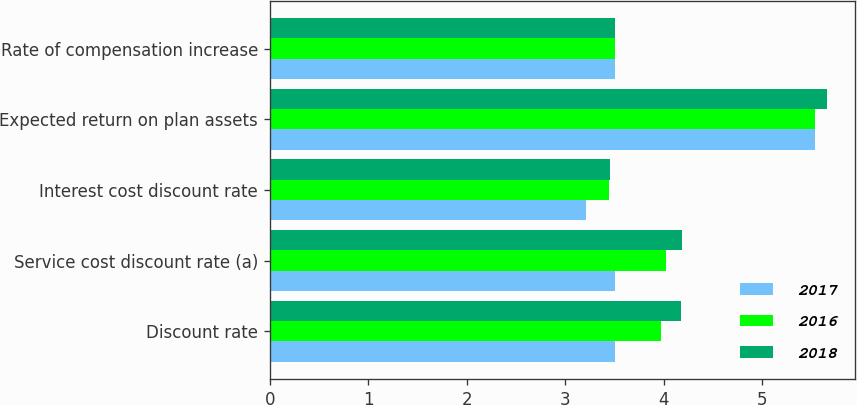Convert chart. <chart><loc_0><loc_0><loc_500><loc_500><stacked_bar_chart><ecel><fcel>Discount rate<fcel>Service cost discount rate (a)<fcel>Interest cost discount rate<fcel>Expected return on plan assets<fcel>Rate of compensation increase<nl><fcel>2017<fcel>3.51<fcel>3.5<fcel>3.21<fcel>5.54<fcel>3.5<nl><fcel>2016<fcel>3.97<fcel>4.02<fcel>3.44<fcel>5.54<fcel>3.5<nl><fcel>2018<fcel>4.17<fcel>4.19<fcel>3.45<fcel>5.66<fcel>3.5<nl></chart> 